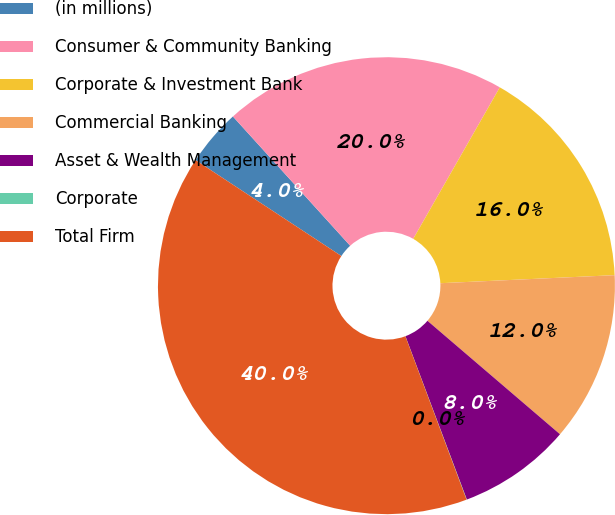Convert chart. <chart><loc_0><loc_0><loc_500><loc_500><pie_chart><fcel>(in millions)<fcel>Consumer & Community Banking<fcel>Corporate & Investment Bank<fcel>Commercial Banking<fcel>Asset & Wealth Management<fcel>Corporate<fcel>Total Firm<nl><fcel>4.01%<fcel>19.99%<fcel>16.0%<fcel>12.0%<fcel>8.01%<fcel>0.02%<fcel>39.96%<nl></chart> 